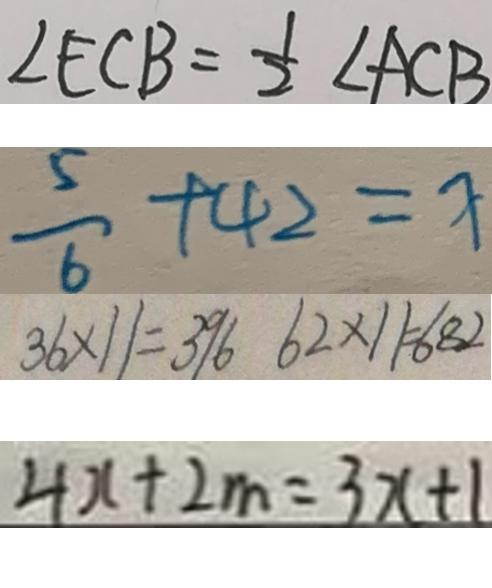<formula> <loc_0><loc_0><loc_500><loc_500>\angle E C B = \frac { 1 } { 2 } \angle A C B 
 \frac { 5 } { 6 } + 4 2 = x 
 3 6 \times 1 1 = 3 9 6 6 2 \times 1 1 = 6 8 2 
 4 x + 2 m = 3 x + 1</formula> 